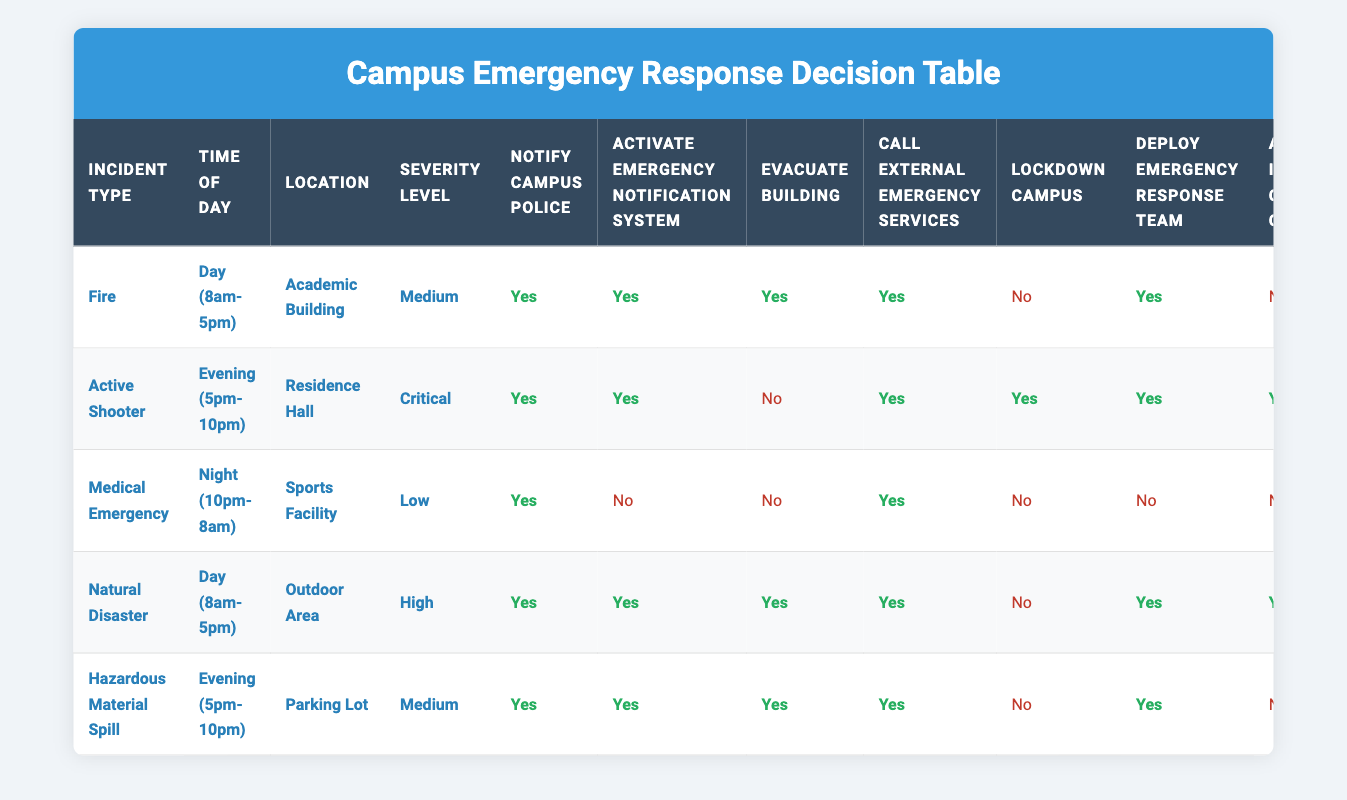What actions should be taken for a fire incident during the day in an academic building with medium severity? According to the table, for a fire incident conditions of Day (8am-5pm), Academic Building, and Medium severity, the actions to be taken are: Notify Campus Police (Yes), Activate Emergency Notification System (Yes), Evacuate Building (Yes), Call External Emergency Services (Yes), Lockdown Campus (No), Deploy Emergency Response Team (Yes), Activate Incident Command Center (No).
Answer: Notify Campus Police: Yes, Activate Emergency Notification System: Yes, Evacuate Building: Yes, Call External Emergency Services: Yes, Lockdown Campus: No, Deploy Emergency Response Team: Yes, Activate Incident Command Center: No Is there a need to evacuate the building during a hazardous material spill in the parking lot at evening? The table indicates that for a hazardous material spill in the Parking Lot during the Evening (5pm-10pm) with Medium severity, the action to Evacuate Building is Yes. Therefore, evacuation is necessary in this scenario.
Answer: Yes What is the highest severity level associated with an active shooter incident? The table shows that during an Active Shooter incident in a Residence Hall during the Evening (5pm-10pm), the severity level is Critical. Thus, Critical is the highest severity level in this case.
Answer: Critical How many actions involve notifying external emergency services for natural disasters and fires? For a Natural Disaster: Call External Emergency Services is Yes. For a Fire incident during the Day (8am-5pm) in an Academic Building with Medium severity, Call External Emergency Services is also Yes. Adding these together gives 2 actions that involve notifying external emergency services.
Answer: 2 Are campus lockdowns required for both natural disasters and active shooter scenarios? The table specifies that for a Natural Disaster during the Day (8am-5pm), Lockdown Campus is No. In contrast, for an Active Shooter scenario in the Residence Hall during the Evening (5pm-10pm), Lockdown Campus is Yes. Therefore, campus lockdowns are not required for natural disasters but are required for active shooters.
Answer: No for natural disaster, Yes for active shooter In the case of a medical emergency at night in the sports facility, should the emergency response team be deployed? According to the table, for a Medical Emergency at Night (10pm-8am) in the Sports Facility with Low severity, the action to Deploy Emergency Response Team is No. Therefore, the emergency response team should not be deployed in this scenario.
Answer: No Which incident during the evening requires locking down the campus? From the table, the Active Shooter incident during the Evening (5pm-10pm) in the Residence Hall requires Lockdown Campus (Yes). Hence, this is the incident that mandates a lockdown.
Answer: Active Shooter What is the action regarding the emergency notification system during a natural disaster? The table states that during a Natural Disaster in an Outdoor Area during the Day (8am-5pm) with High severity, the action for Activate Emergency Notification System is Yes. Therefore, the emergency notification system should be activated in this scenario.
Answer: Yes 